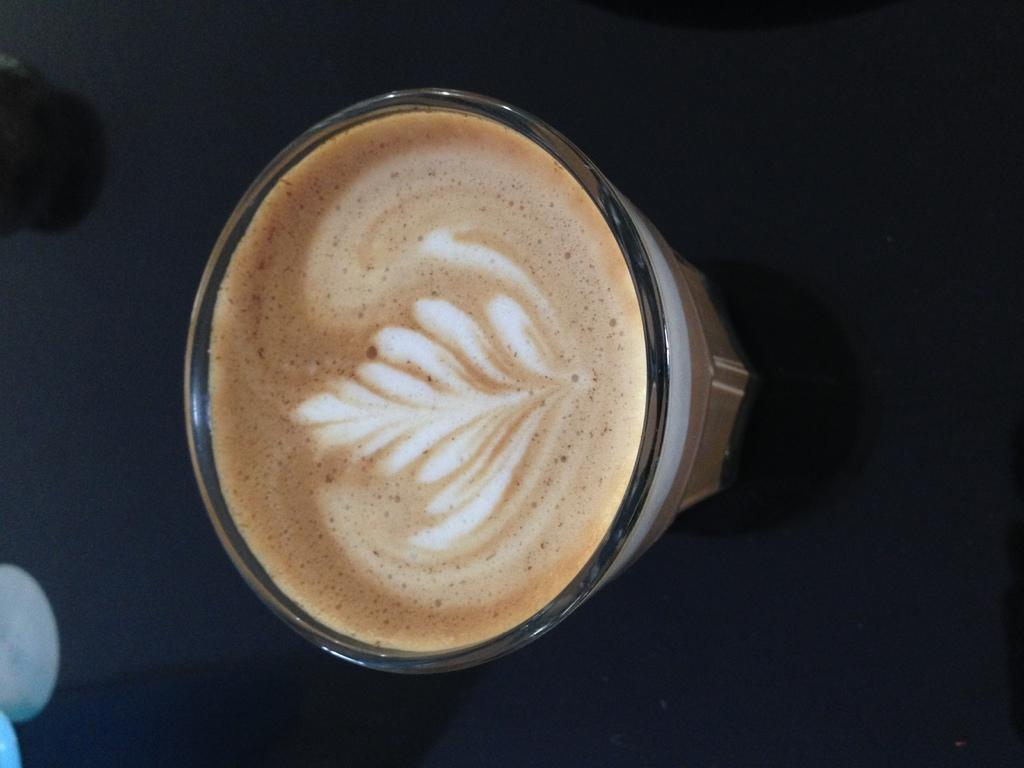What is in the glass that is visible in the image? There is a coffee in the glass. What can be seen in the background of the image? There is a black surface in the background of the image. What is located on the left side of the image? There are objects on the left side of the image. How many rays of sunlight can be seen coming through the window in the image? There is no window or sunlight visible in the image; it only shows a glass with coffee and a black surface in the background. 